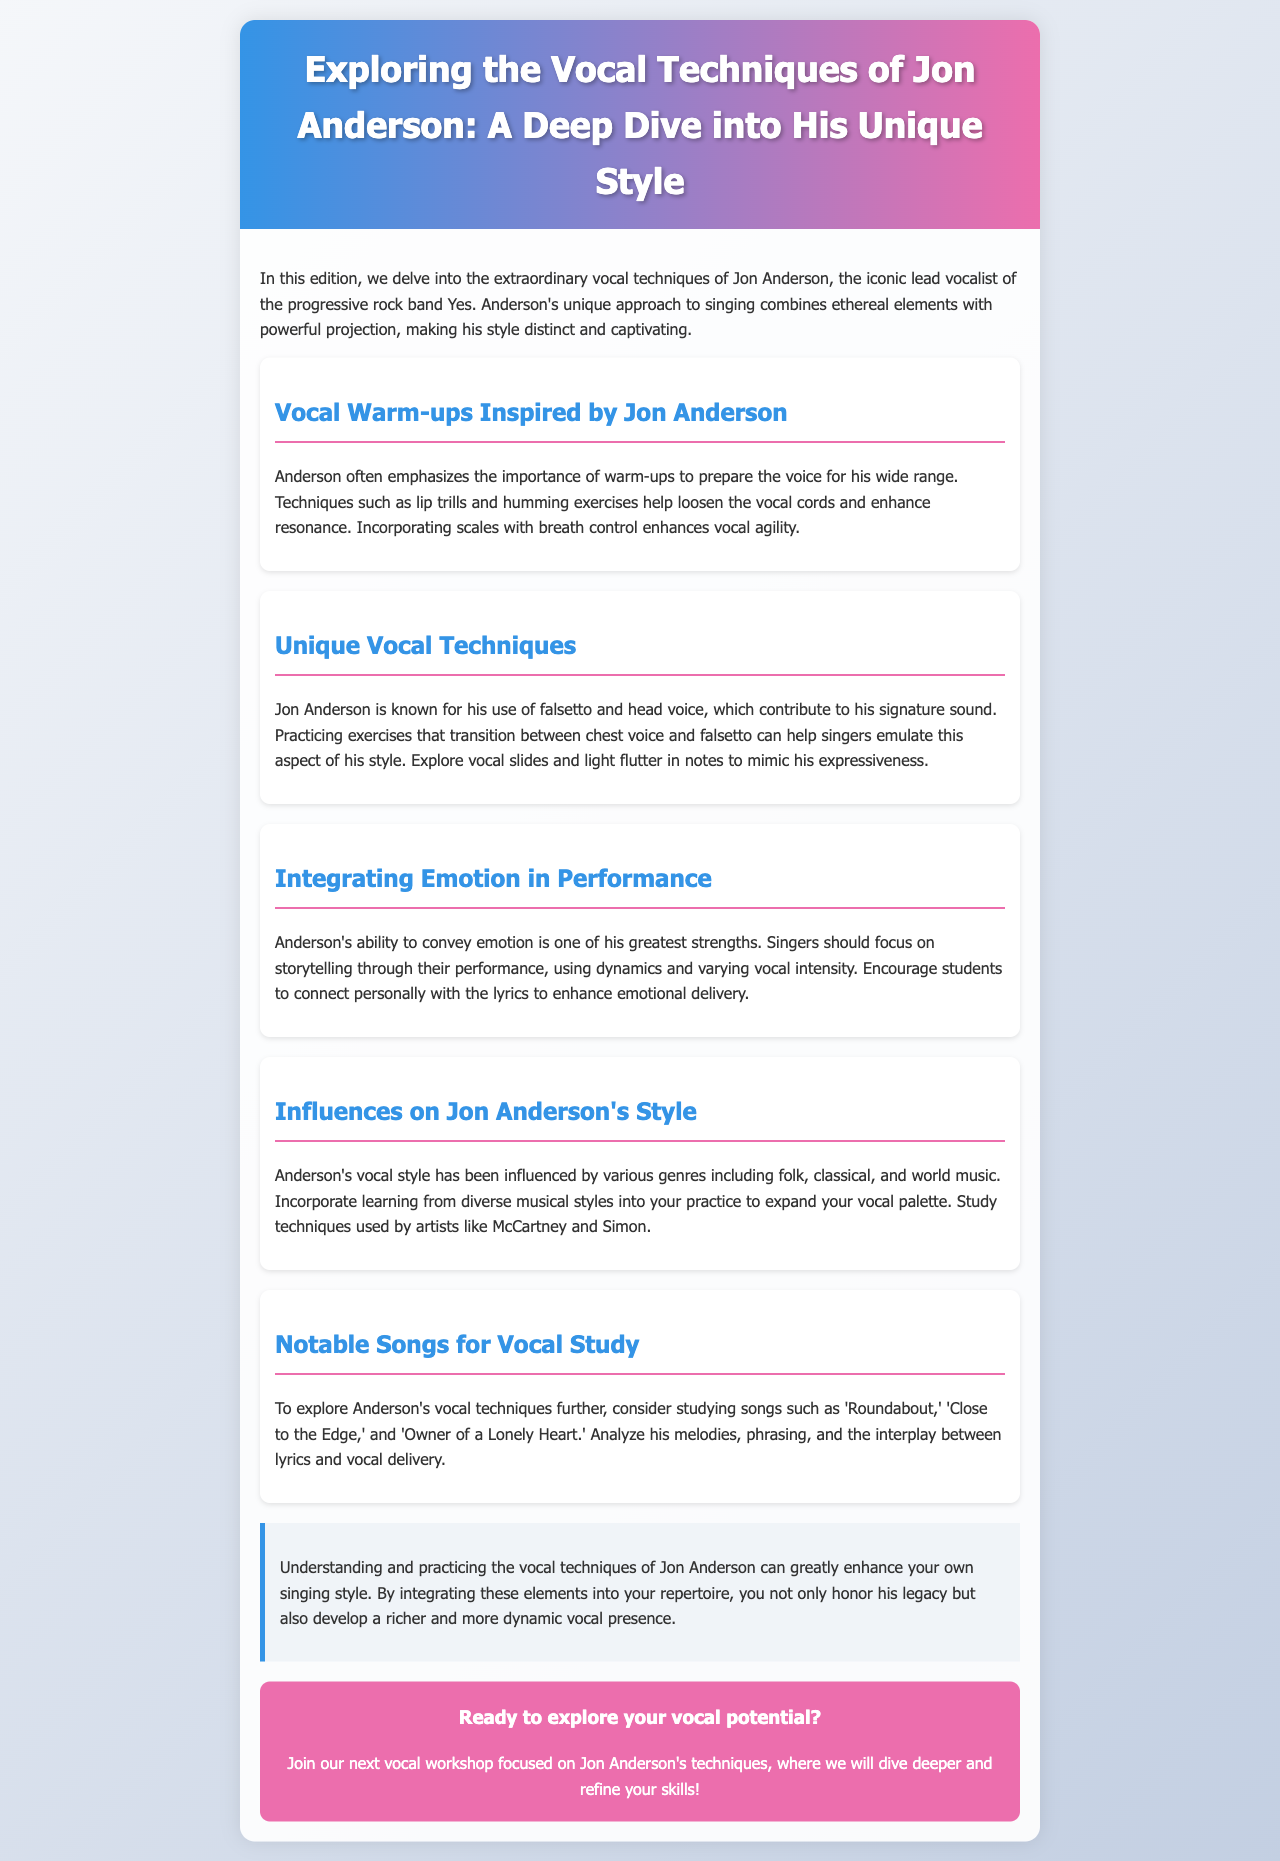What is Jon Anderson known for? Jon Anderson is known for being the iconic lead vocalist of the progressive rock band Yes.
Answer: Lead vocalist of Yes What does Jon Anderson emphasize for vocal preparation? Anderson emphasizes the importance of warm-ups to prepare the voice.
Answer: Warm-ups Name one exercise mentioned for vocal warm-ups. The document mentions lip trills as an exercise for warm-ups.
Answer: Lip trills Which vocal techniques contribute to Anderson's signature sound? Anderson's signature sound is contributed by his use of falsetto and head voice.
Answer: Falsetto and head voice What is one way to enhance emotional delivery in singing? Singers should focus on storytelling through their performance.
Answer: Storytelling Which notable song is suggested for vocal study? 'Roundabout' is one of the notable songs suggested for vocal study.
Answer: 'Roundabout' What should singers incorporate from various musical styles? Singers should incorporate learning from diverse musical styles into their practice.
Answer: Learning from diverse musical styles What is one emotional aspect of Anderson's performance style? One emotional aspect is his ability to convey emotion through dynamics and vocal intensity.
Answer: Convey emotion What type of workshop is being promoted? The newsletter promotes a vocal workshop focused on Jon Anderson's techniques.
Answer: Vocal workshop 